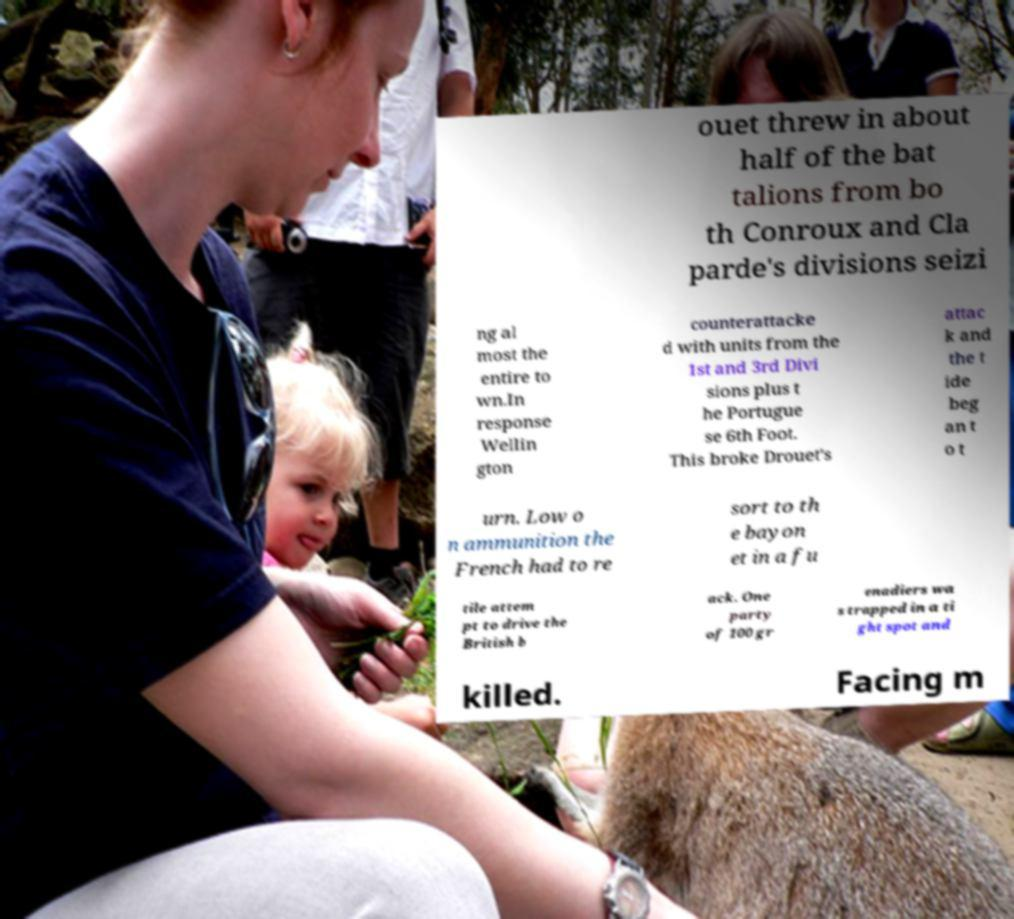For documentation purposes, I need the text within this image transcribed. Could you provide that? ouet threw in about half of the bat talions from bo th Conroux and Cla parde's divisions seizi ng al most the entire to wn.In response Wellin gton counterattacke d with units from the 1st and 3rd Divi sions plus t he Portugue se 6th Foot. This broke Drouet's attac k and the t ide beg an t o t urn. Low o n ammunition the French had to re sort to th e bayon et in a fu tile attem pt to drive the British b ack. One party of 100 gr enadiers wa s trapped in a ti ght spot and killed. Facing m 